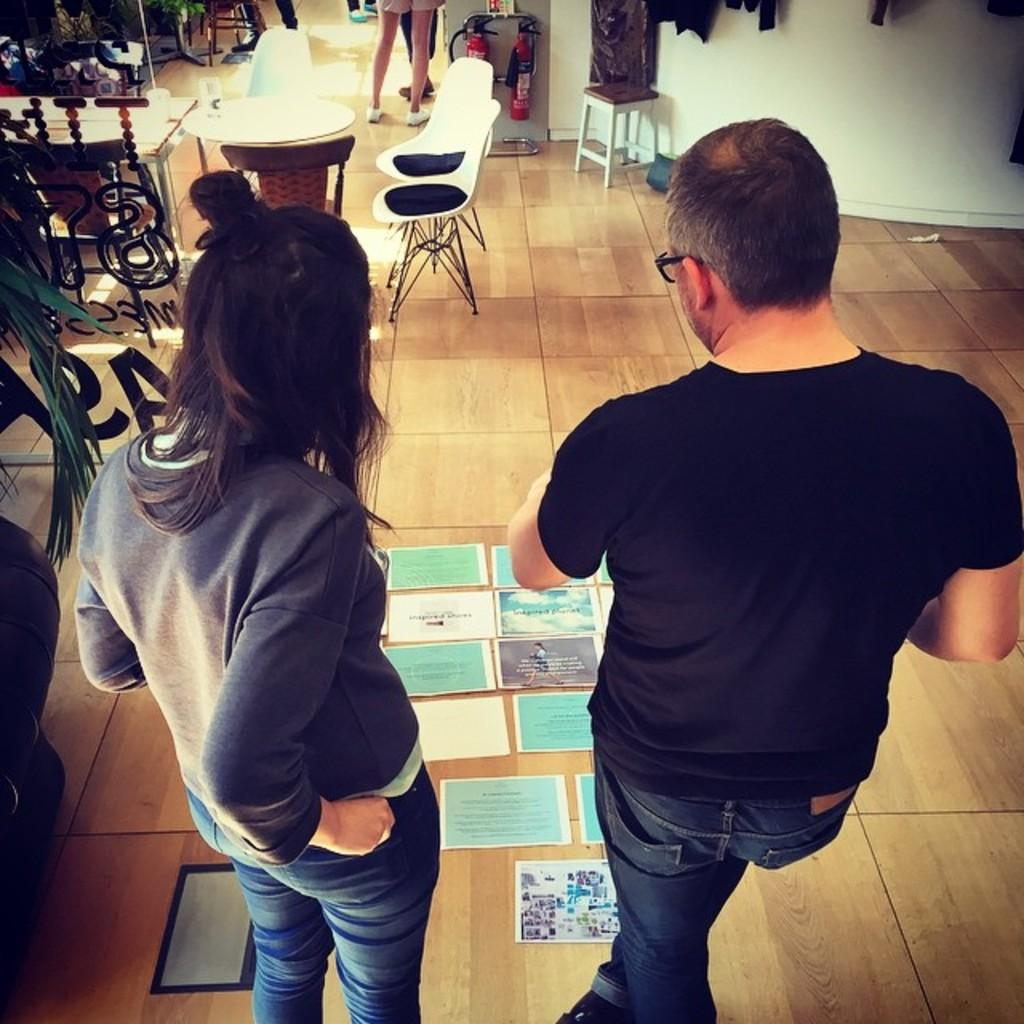How many people are in the image? There are two persons standing in the image. What can be seen on the floor in the image? There are different types of posters on the floor. What type of furniture is visible in the image? Chairs and tables are present in the image. Where is the fire extinguisher located in the image? The fire extinguisher is on the wall in the image. What is the family's opinion on the kite in the image? There is no mention of a family or a kite in the image, so it is not possible to determine their opinion. 